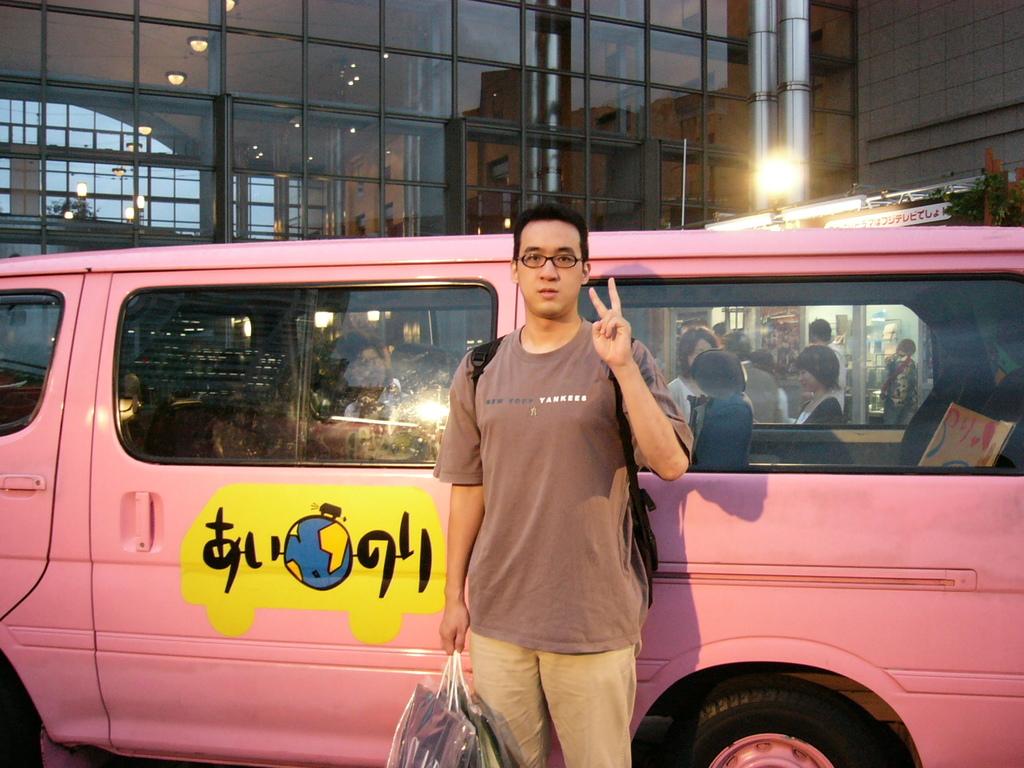What does his shirt say?
Your answer should be very brief. New york yankees. 